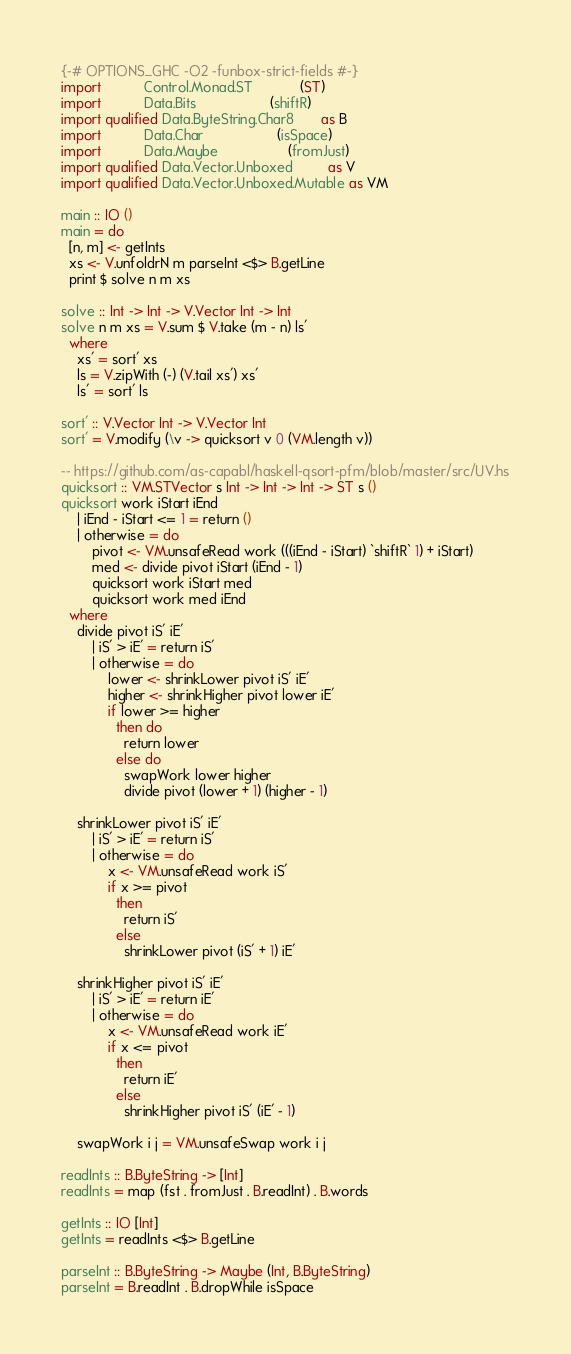Convert code to text. <code><loc_0><loc_0><loc_500><loc_500><_Haskell_>{-# OPTIONS_GHC -O2 -funbox-strict-fields #-}
import           Control.Monad.ST            (ST)
import           Data.Bits                   (shiftR)
import qualified Data.ByteString.Char8       as B
import           Data.Char                   (isSpace)
import           Data.Maybe                  (fromJust)
import qualified Data.Vector.Unboxed         as V
import qualified Data.Vector.Unboxed.Mutable as VM

main :: IO ()
main = do
  [n, m] <- getInts
  xs <- V.unfoldrN m parseInt <$> B.getLine
  print $ solve n m xs

solve :: Int -> Int -> V.Vector Int -> Int
solve n m xs = V.sum $ V.take (m - n) ls'
  where
    xs' = sort' xs
    ls = V.zipWith (-) (V.tail xs') xs'
    ls' = sort' ls

sort' :: V.Vector Int -> V.Vector Int
sort' = V.modify (\v -> quicksort v 0 (VM.length v))

-- https://github.com/as-capabl/haskell-qsort-pfm/blob/master/src/UV.hs
quicksort :: VM.STVector s Int -> Int -> Int -> ST s ()
quicksort work iStart iEnd
    | iEnd - iStart <= 1 = return ()
    | otherwise = do
        pivot <- VM.unsafeRead work (((iEnd - iStart) `shiftR` 1) + iStart)
        med <- divide pivot iStart (iEnd - 1)
        quicksort work iStart med
        quicksort work med iEnd
  where
    divide pivot iS' iE'
        | iS' > iE' = return iS'
        | otherwise = do
            lower <- shrinkLower pivot iS' iE'
            higher <- shrinkHigher pivot lower iE'
            if lower >= higher
              then do
                return lower
              else do
                swapWork lower higher
                divide pivot (lower + 1) (higher - 1)

    shrinkLower pivot iS' iE'
        | iS' > iE' = return iS'
        | otherwise = do
            x <- VM.unsafeRead work iS'
            if x >= pivot
              then
                return iS'
              else
                shrinkLower pivot (iS' + 1) iE'

    shrinkHigher pivot iS' iE'
        | iS' > iE' = return iE'
        | otherwise = do
            x <- VM.unsafeRead work iE'
            if x <= pivot
              then
                return iE'
              else
                shrinkHigher pivot iS' (iE' - 1)

    swapWork i j = VM.unsafeSwap work i j

readInts :: B.ByteString -> [Int]
readInts = map (fst . fromJust . B.readInt) . B.words

getInts :: IO [Int]
getInts = readInts <$> B.getLine

parseInt :: B.ByteString -> Maybe (Int, B.ByteString)
parseInt = B.readInt . B.dropWhile isSpace
</code> 